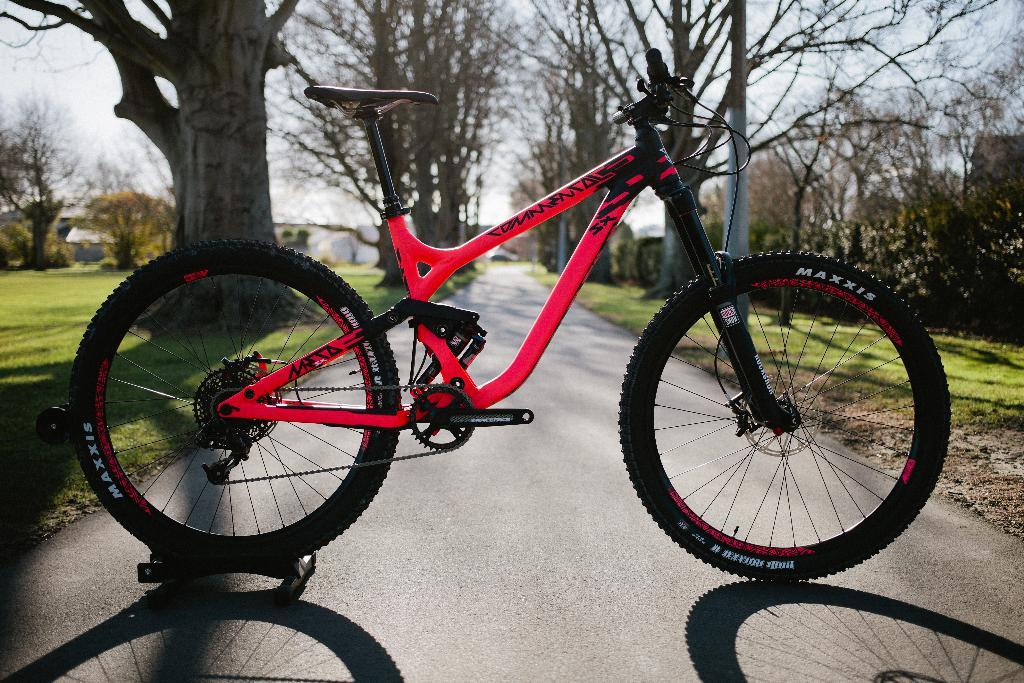What is the main object in the image? There is a bicycle in the image. What type of vegetation is present in the image? There are trees and grass in the image. What can be seen in the background of the image? There are trees in the background of the image. What is visible at the top of the image? The sky is visible at the top of the image. How much money is being exchanged in the image? There is no mention of money or any exchange in the image; it features a bicycle, trees, grass, and the sky. 